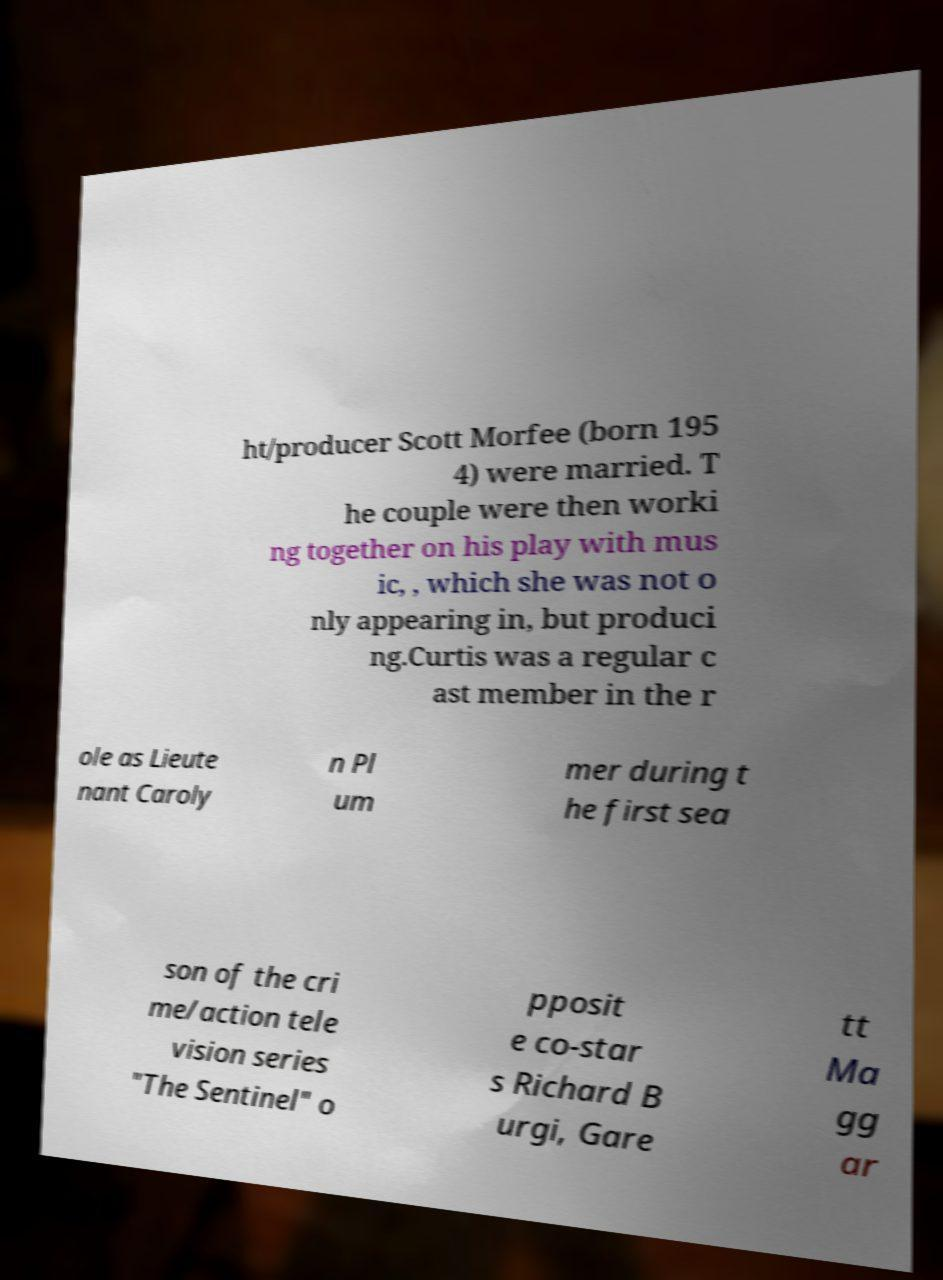For documentation purposes, I need the text within this image transcribed. Could you provide that? ht/producer Scott Morfee (born 195 4) were married. T he couple were then worki ng together on his play with mus ic, , which she was not o nly appearing in, but produci ng.Curtis was a regular c ast member in the r ole as Lieute nant Caroly n Pl um mer during t he first sea son of the cri me/action tele vision series "The Sentinel" o pposit e co-star s Richard B urgi, Gare tt Ma gg ar 